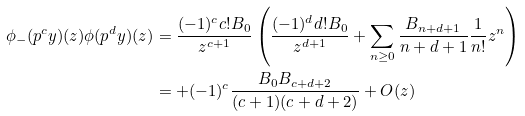Convert formula to latex. <formula><loc_0><loc_0><loc_500><loc_500>\phi _ { - } ( p ^ { c } y ) ( z ) \phi ( p ^ { d } y ) ( z ) & = \frac { ( - 1 ) ^ { c } c ! B _ { 0 } } { z ^ { c + 1 } } \left ( \frac { ( - 1 ) ^ { d } d ! B _ { 0 } } { z ^ { d + 1 } } + \sum _ { n \geq 0 } \frac { B _ { n + d + 1 } } { n + d + 1 } \frac { 1 } { n ! } z ^ { n } \right ) \\ & = + ( - 1 ) ^ { c } \frac { B _ { 0 } B _ { c + d + 2 } } { ( c + 1 ) ( c + d + 2 ) } + O ( z )</formula> 